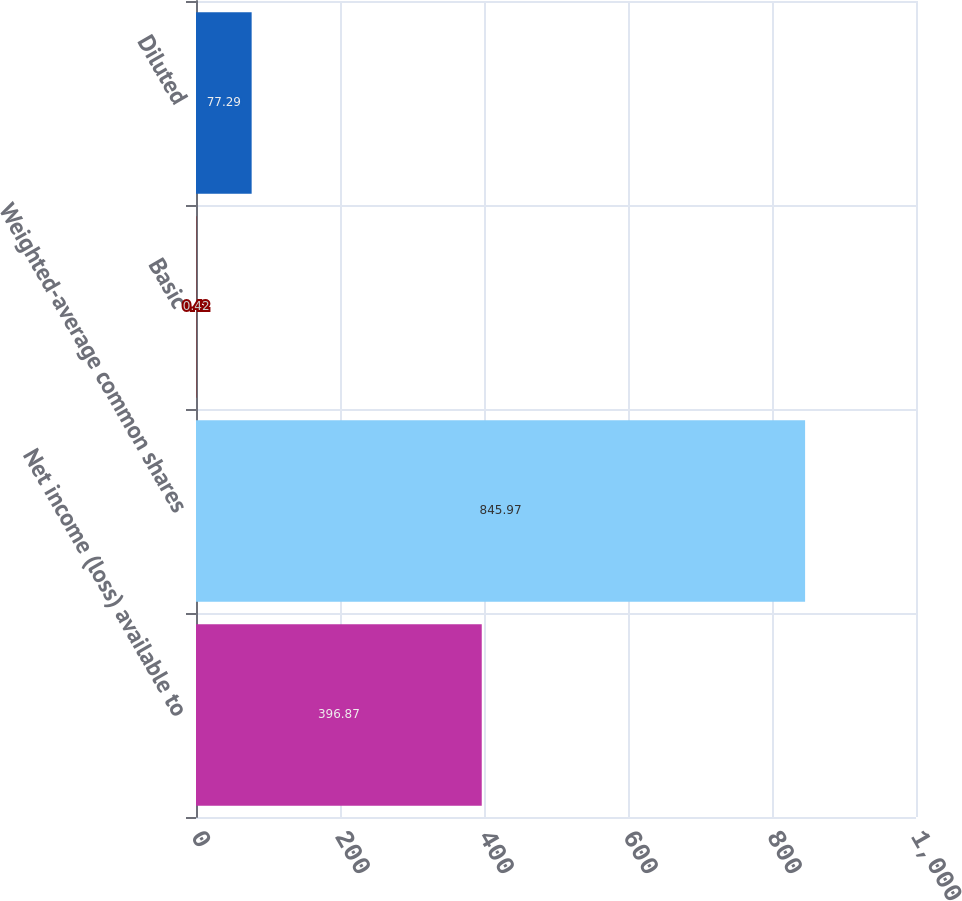<chart> <loc_0><loc_0><loc_500><loc_500><bar_chart><fcel>Net income (loss) available to<fcel>Weighted-average common shares<fcel>Basic<fcel>Diluted<nl><fcel>396.87<fcel>845.97<fcel>0.42<fcel>77.29<nl></chart> 